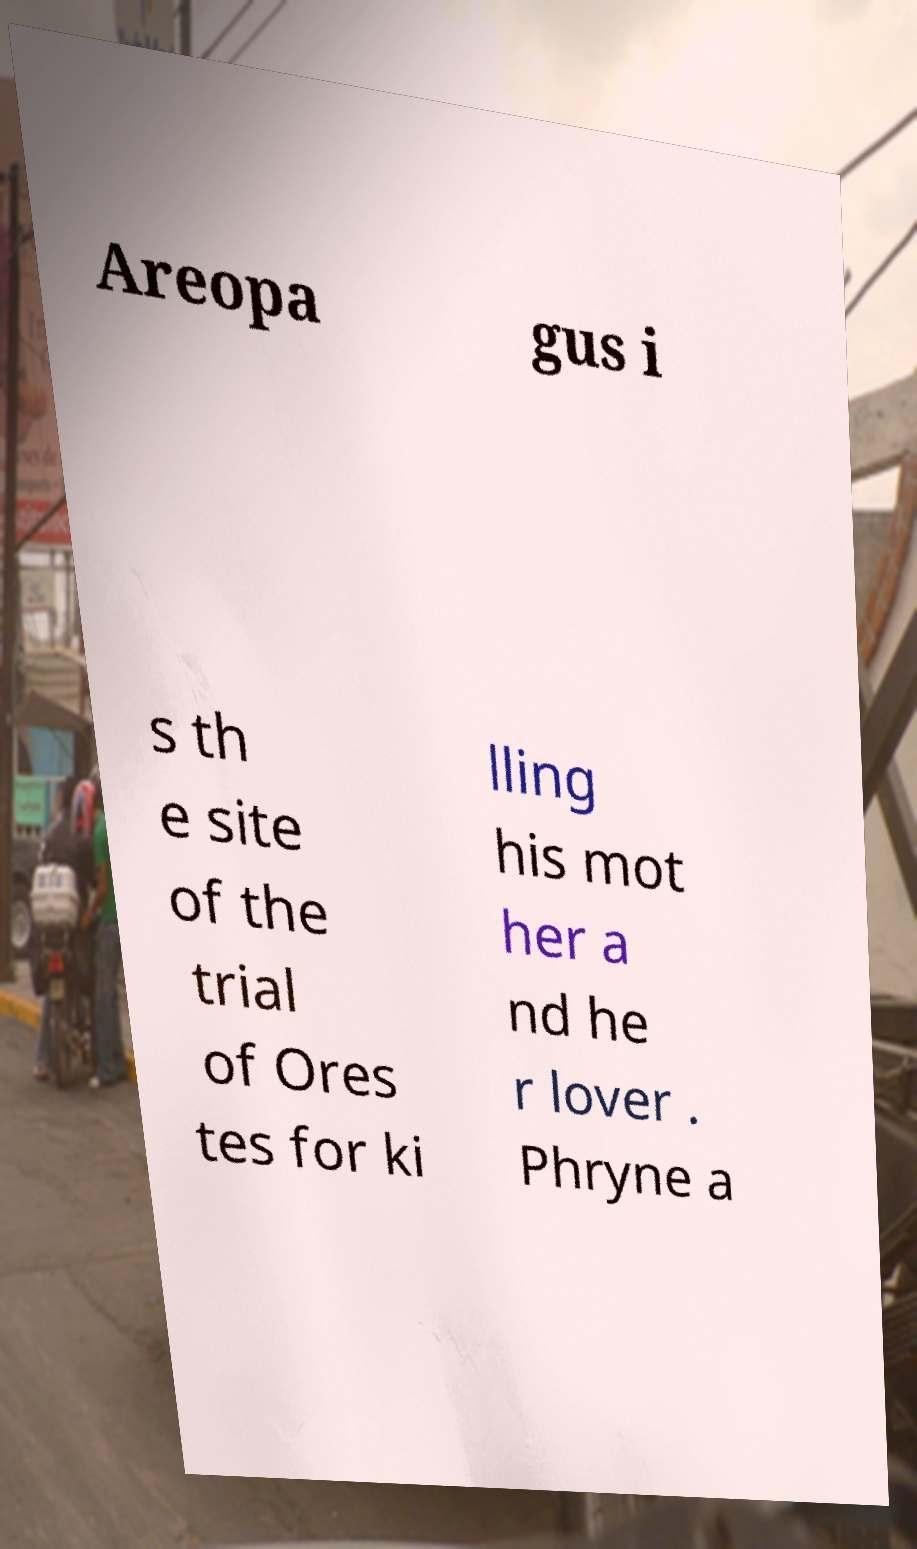Could you assist in decoding the text presented in this image and type it out clearly? Areopa gus i s th e site of the trial of Ores tes for ki lling his mot her a nd he r lover . Phryne a 